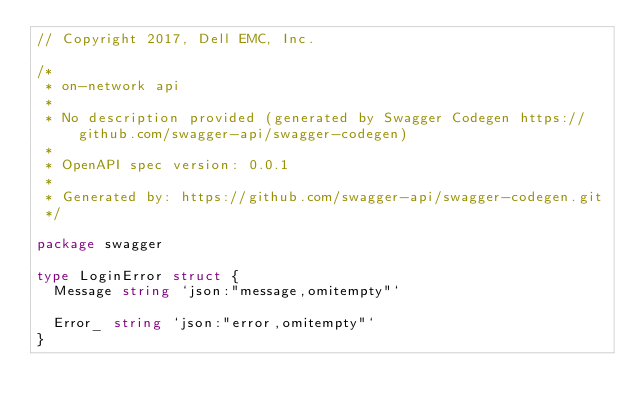<code> <loc_0><loc_0><loc_500><loc_500><_Go_>// Copyright 2017, Dell EMC, Inc.

/*
 * on-network api
 *
 * No description provided (generated by Swagger Codegen https://github.com/swagger-api/swagger-codegen)
 *
 * OpenAPI spec version: 0.0.1
 *
 * Generated by: https://github.com/swagger-api/swagger-codegen.git
 */

package swagger

type LoginError struct {
	Message string `json:"message,omitempty"`

	Error_ string `json:"error,omitempty"`
}
</code> 